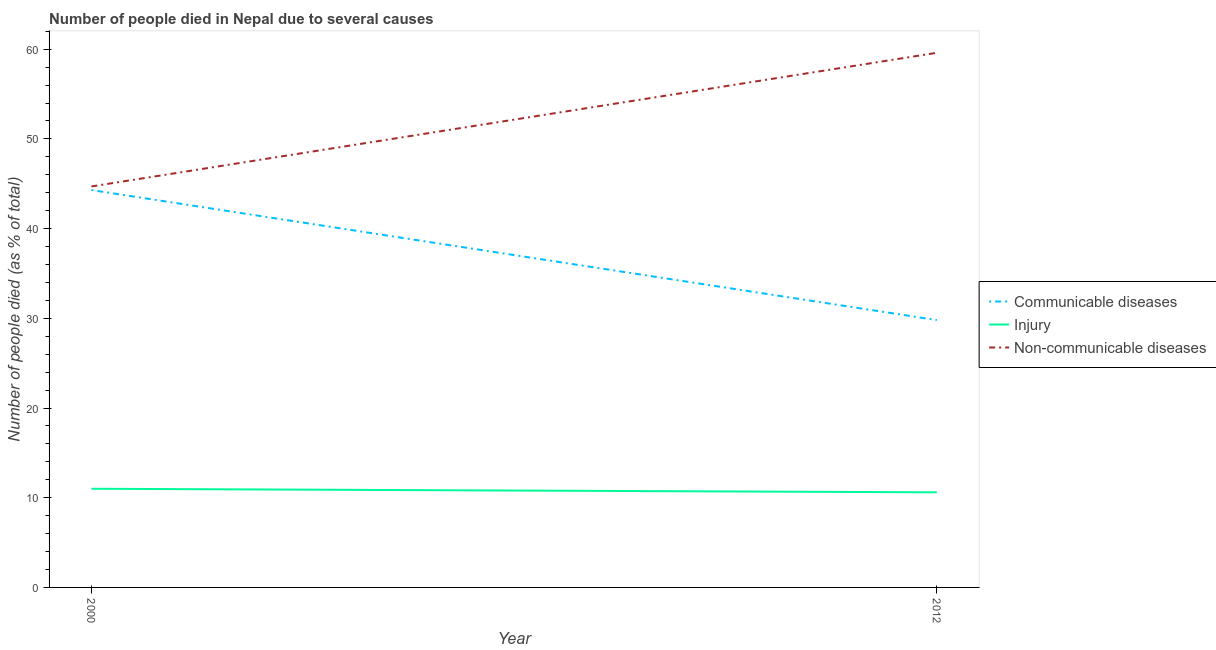How many different coloured lines are there?
Provide a short and direct response. 3. Is the number of lines equal to the number of legend labels?
Your response must be concise. Yes. What is the number of people who died of communicable diseases in 2000?
Offer a terse response. 44.3. Across all years, what is the maximum number of people who dies of non-communicable diseases?
Your answer should be very brief. 59.6. Across all years, what is the minimum number of people who dies of non-communicable diseases?
Keep it short and to the point. 44.7. In which year was the number of people who dies of non-communicable diseases maximum?
Your answer should be very brief. 2012. In which year was the number of people who dies of non-communicable diseases minimum?
Keep it short and to the point. 2000. What is the total number of people who dies of non-communicable diseases in the graph?
Your response must be concise. 104.3. What is the difference between the number of people who died of injury in 2000 and that in 2012?
Offer a terse response. 0.4. What is the average number of people who died of injury per year?
Ensure brevity in your answer.  10.8. In the year 2000, what is the difference between the number of people who died of injury and number of people who dies of non-communicable diseases?
Provide a succinct answer. -33.7. In how many years, is the number of people who dies of non-communicable diseases greater than 20 %?
Give a very brief answer. 2. What is the ratio of the number of people who died of communicable diseases in 2000 to that in 2012?
Offer a terse response. 1.49. In how many years, is the number of people who died of communicable diseases greater than the average number of people who died of communicable diseases taken over all years?
Give a very brief answer. 1. Is it the case that in every year, the sum of the number of people who died of communicable diseases and number of people who died of injury is greater than the number of people who dies of non-communicable diseases?
Offer a terse response. No. Is the number of people who dies of non-communicable diseases strictly greater than the number of people who died of communicable diseases over the years?
Provide a short and direct response. Yes. How many lines are there?
Provide a short and direct response. 3. What is the difference between two consecutive major ticks on the Y-axis?
Offer a terse response. 10. Does the graph contain any zero values?
Ensure brevity in your answer.  No. Does the graph contain grids?
Your response must be concise. No. Where does the legend appear in the graph?
Your answer should be compact. Center right. How many legend labels are there?
Your answer should be very brief. 3. What is the title of the graph?
Your answer should be compact. Number of people died in Nepal due to several causes. Does "Oil sources" appear as one of the legend labels in the graph?
Keep it short and to the point. No. What is the label or title of the Y-axis?
Ensure brevity in your answer.  Number of people died (as % of total). What is the Number of people died (as % of total) of Communicable diseases in 2000?
Give a very brief answer. 44.3. What is the Number of people died (as % of total) of Non-communicable diseases in 2000?
Your answer should be compact. 44.7. What is the Number of people died (as % of total) of Communicable diseases in 2012?
Provide a short and direct response. 29.8. What is the Number of people died (as % of total) of Non-communicable diseases in 2012?
Ensure brevity in your answer.  59.6. Across all years, what is the maximum Number of people died (as % of total) in Communicable diseases?
Provide a succinct answer. 44.3. Across all years, what is the maximum Number of people died (as % of total) in Injury?
Offer a very short reply. 11. Across all years, what is the maximum Number of people died (as % of total) of Non-communicable diseases?
Offer a terse response. 59.6. Across all years, what is the minimum Number of people died (as % of total) in Communicable diseases?
Offer a very short reply. 29.8. Across all years, what is the minimum Number of people died (as % of total) of Injury?
Provide a short and direct response. 10.6. Across all years, what is the minimum Number of people died (as % of total) of Non-communicable diseases?
Your answer should be compact. 44.7. What is the total Number of people died (as % of total) in Communicable diseases in the graph?
Make the answer very short. 74.1. What is the total Number of people died (as % of total) in Injury in the graph?
Your answer should be compact. 21.6. What is the total Number of people died (as % of total) of Non-communicable diseases in the graph?
Your response must be concise. 104.3. What is the difference between the Number of people died (as % of total) in Communicable diseases in 2000 and that in 2012?
Provide a succinct answer. 14.5. What is the difference between the Number of people died (as % of total) in Non-communicable diseases in 2000 and that in 2012?
Offer a very short reply. -14.9. What is the difference between the Number of people died (as % of total) of Communicable diseases in 2000 and the Number of people died (as % of total) of Injury in 2012?
Provide a short and direct response. 33.7. What is the difference between the Number of people died (as % of total) in Communicable diseases in 2000 and the Number of people died (as % of total) in Non-communicable diseases in 2012?
Your answer should be very brief. -15.3. What is the difference between the Number of people died (as % of total) of Injury in 2000 and the Number of people died (as % of total) of Non-communicable diseases in 2012?
Provide a succinct answer. -48.6. What is the average Number of people died (as % of total) of Communicable diseases per year?
Offer a very short reply. 37.05. What is the average Number of people died (as % of total) in Injury per year?
Your response must be concise. 10.8. What is the average Number of people died (as % of total) in Non-communicable diseases per year?
Provide a short and direct response. 52.15. In the year 2000, what is the difference between the Number of people died (as % of total) of Communicable diseases and Number of people died (as % of total) of Injury?
Your answer should be very brief. 33.3. In the year 2000, what is the difference between the Number of people died (as % of total) of Communicable diseases and Number of people died (as % of total) of Non-communicable diseases?
Your response must be concise. -0.4. In the year 2000, what is the difference between the Number of people died (as % of total) of Injury and Number of people died (as % of total) of Non-communicable diseases?
Your response must be concise. -33.7. In the year 2012, what is the difference between the Number of people died (as % of total) of Communicable diseases and Number of people died (as % of total) of Injury?
Offer a terse response. 19.2. In the year 2012, what is the difference between the Number of people died (as % of total) in Communicable diseases and Number of people died (as % of total) in Non-communicable diseases?
Provide a succinct answer. -29.8. In the year 2012, what is the difference between the Number of people died (as % of total) in Injury and Number of people died (as % of total) in Non-communicable diseases?
Offer a terse response. -49. What is the ratio of the Number of people died (as % of total) in Communicable diseases in 2000 to that in 2012?
Offer a very short reply. 1.49. What is the ratio of the Number of people died (as % of total) of Injury in 2000 to that in 2012?
Keep it short and to the point. 1.04. What is the difference between the highest and the second highest Number of people died (as % of total) of Communicable diseases?
Make the answer very short. 14.5. What is the difference between the highest and the second highest Number of people died (as % of total) in Non-communicable diseases?
Your response must be concise. 14.9. What is the difference between the highest and the lowest Number of people died (as % of total) of Communicable diseases?
Make the answer very short. 14.5. What is the difference between the highest and the lowest Number of people died (as % of total) of Non-communicable diseases?
Offer a terse response. 14.9. 